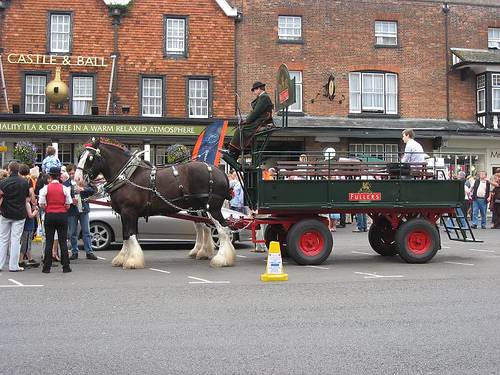Please extract the text content from this image. FULLERS RELAXED IN A COFFEE BALL CASTLE 